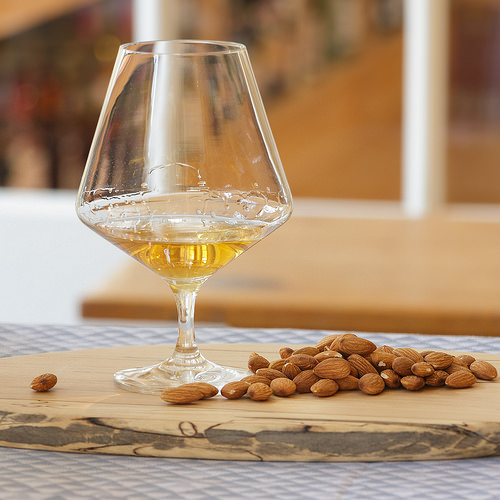<image>
Is there a drink on the board? Yes. Looking at the image, I can see the drink is positioned on top of the board, with the board providing support. Where is the nut in relation to the table? Is it on the table? No. The nut is not positioned on the table. They may be near each other, but the nut is not supported by or resting on top of the table. Is there a nuts in the glass? No. The nuts is not contained within the glass. These objects have a different spatial relationship. Is the almond in front of the glass? Yes. The almond is positioned in front of the glass, appearing closer to the camera viewpoint. 